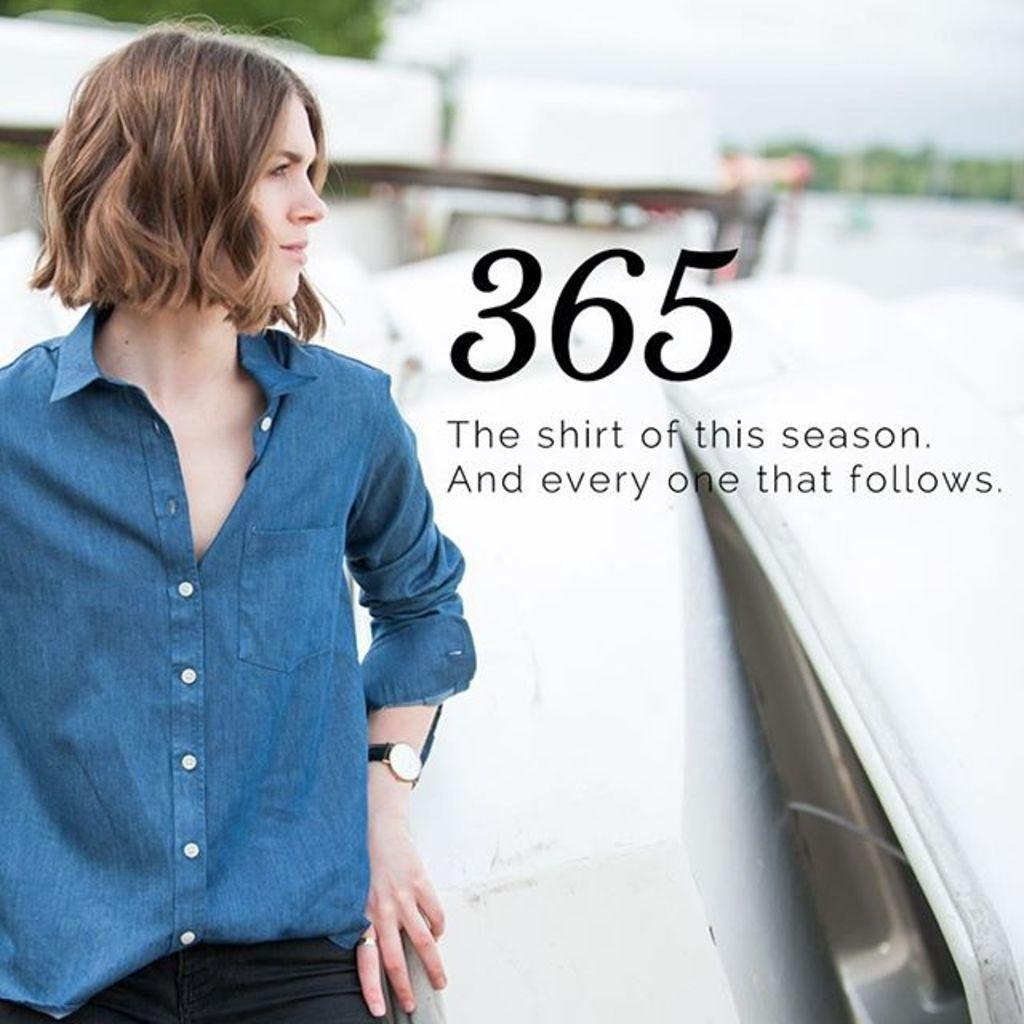What is the main subject of the image? There is a woman standing in the image. What is the woman wearing? The woman is wearing a shirt. What else can be seen in the image besides the woman? There is text visible in the image. How would you describe the background of the image? The background of the image is blurred. What type of cabbage is being used as a design element in the woman's shirt? There is no cabbage present in the image, nor is it being used as a design element in the woman's shirt. 